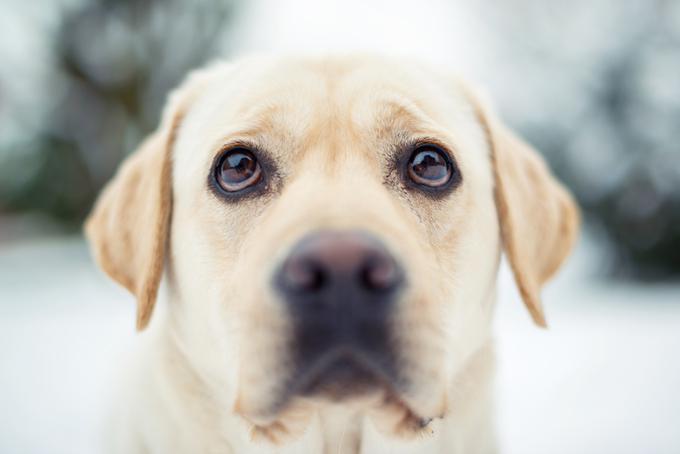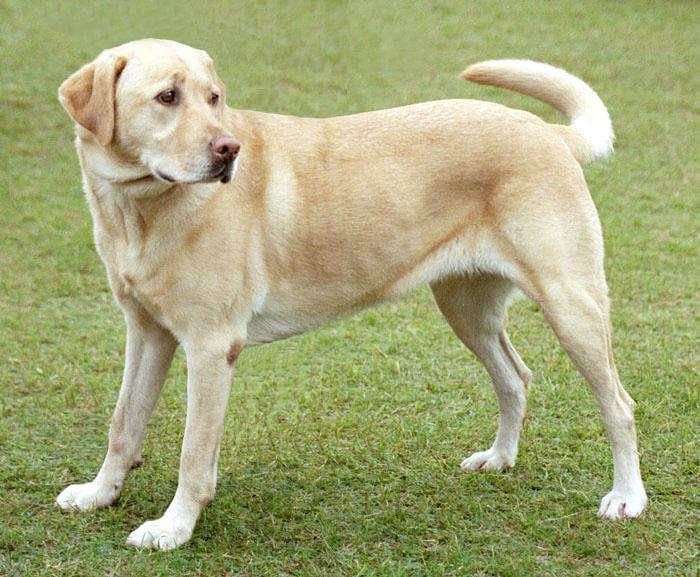The first image is the image on the left, the second image is the image on the right. For the images displayed, is the sentence "In one of the images there is a single yellow lab standing on all fours on the ground outside." factually correct? Answer yes or no. Yes. 